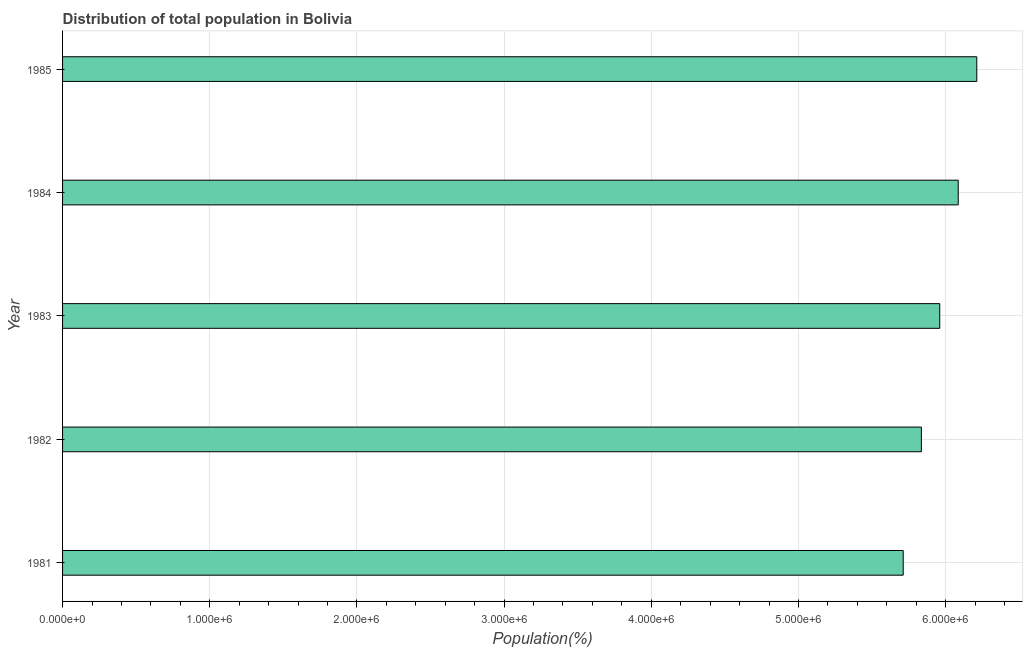Does the graph contain grids?
Offer a very short reply. Yes. What is the title of the graph?
Offer a very short reply. Distribution of total population in Bolivia . What is the label or title of the X-axis?
Your answer should be compact. Population(%). What is the population in 1981?
Your response must be concise. 5.71e+06. Across all years, what is the maximum population?
Keep it short and to the point. 6.21e+06. Across all years, what is the minimum population?
Give a very brief answer. 5.71e+06. In which year was the population maximum?
Your answer should be very brief. 1985. What is the sum of the population?
Make the answer very short. 2.98e+07. What is the difference between the population in 1982 and 1983?
Provide a short and direct response. -1.25e+05. What is the average population per year?
Your answer should be very brief. 5.96e+06. What is the median population?
Your answer should be very brief. 5.96e+06. Do a majority of the years between 1984 and 1985 (inclusive) have population greater than 4000000 %?
Your answer should be very brief. Yes. What is the ratio of the population in 1981 to that in 1984?
Your answer should be compact. 0.94. Is the population in 1981 less than that in 1984?
Ensure brevity in your answer.  Yes. What is the difference between the highest and the second highest population?
Provide a short and direct response. 1.26e+05. Is the sum of the population in 1982 and 1983 greater than the maximum population across all years?
Offer a terse response. Yes. What is the difference between the highest and the lowest population?
Your answer should be compact. 5.00e+05. Are all the bars in the graph horizontal?
Your answer should be very brief. Yes. What is the difference between two consecutive major ticks on the X-axis?
Make the answer very short. 1.00e+06. What is the Population(%) in 1981?
Give a very brief answer. 5.71e+06. What is the Population(%) of 1982?
Ensure brevity in your answer.  5.84e+06. What is the Population(%) of 1983?
Give a very brief answer. 5.96e+06. What is the Population(%) in 1984?
Your response must be concise. 6.09e+06. What is the Population(%) of 1985?
Give a very brief answer. 6.21e+06. What is the difference between the Population(%) in 1981 and 1982?
Keep it short and to the point. -1.24e+05. What is the difference between the Population(%) in 1981 and 1983?
Provide a short and direct response. -2.48e+05. What is the difference between the Population(%) in 1981 and 1984?
Offer a terse response. -3.74e+05. What is the difference between the Population(%) in 1981 and 1985?
Give a very brief answer. -5.00e+05. What is the difference between the Population(%) in 1982 and 1983?
Your answer should be compact. -1.25e+05. What is the difference between the Population(%) in 1982 and 1984?
Keep it short and to the point. -2.50e+05. What is the difference between the Population(%) in 1982 and 1985?
Your response must be concise. -3.76e+05. What is the difference between the Population(%) in 1983 and 1984?
Provide a short and direct response. -1.26e+05. What is the difference between the Population(%) in 1983 and 1985?
Make the answer very short. -2.52e+05. What is the difference between the Population(%) in 1984 and 1985?
Keep it short and to the point. -1.26e+05. What is the ratio of the Population(%) in 1981 to that in 1982?
Offer a very short reply. 0.98. What is the ratio of the Population(%) in 1981 to that in 1983?
Provide a succinct answer. 0.96. What is the ratio of the Population(%) in 1981 to that in 1984?
Your answer should be compact. 0.94. What is the ratio of the Population(%) in 1981 to that in 1985?
Ensure brevity in your answer.  0.92. What is the ratio of the Population(%) in 1982 to that in 1984?
Ensure brevity in your answer.  0.96. What is the ratio of the Population(%) in 1982 to that in 1985?
Offer a very short reply. 0.94. What is the ratio of the Population(%) in 1984 to that in 1985?
Your response must be concise. 0.98. 